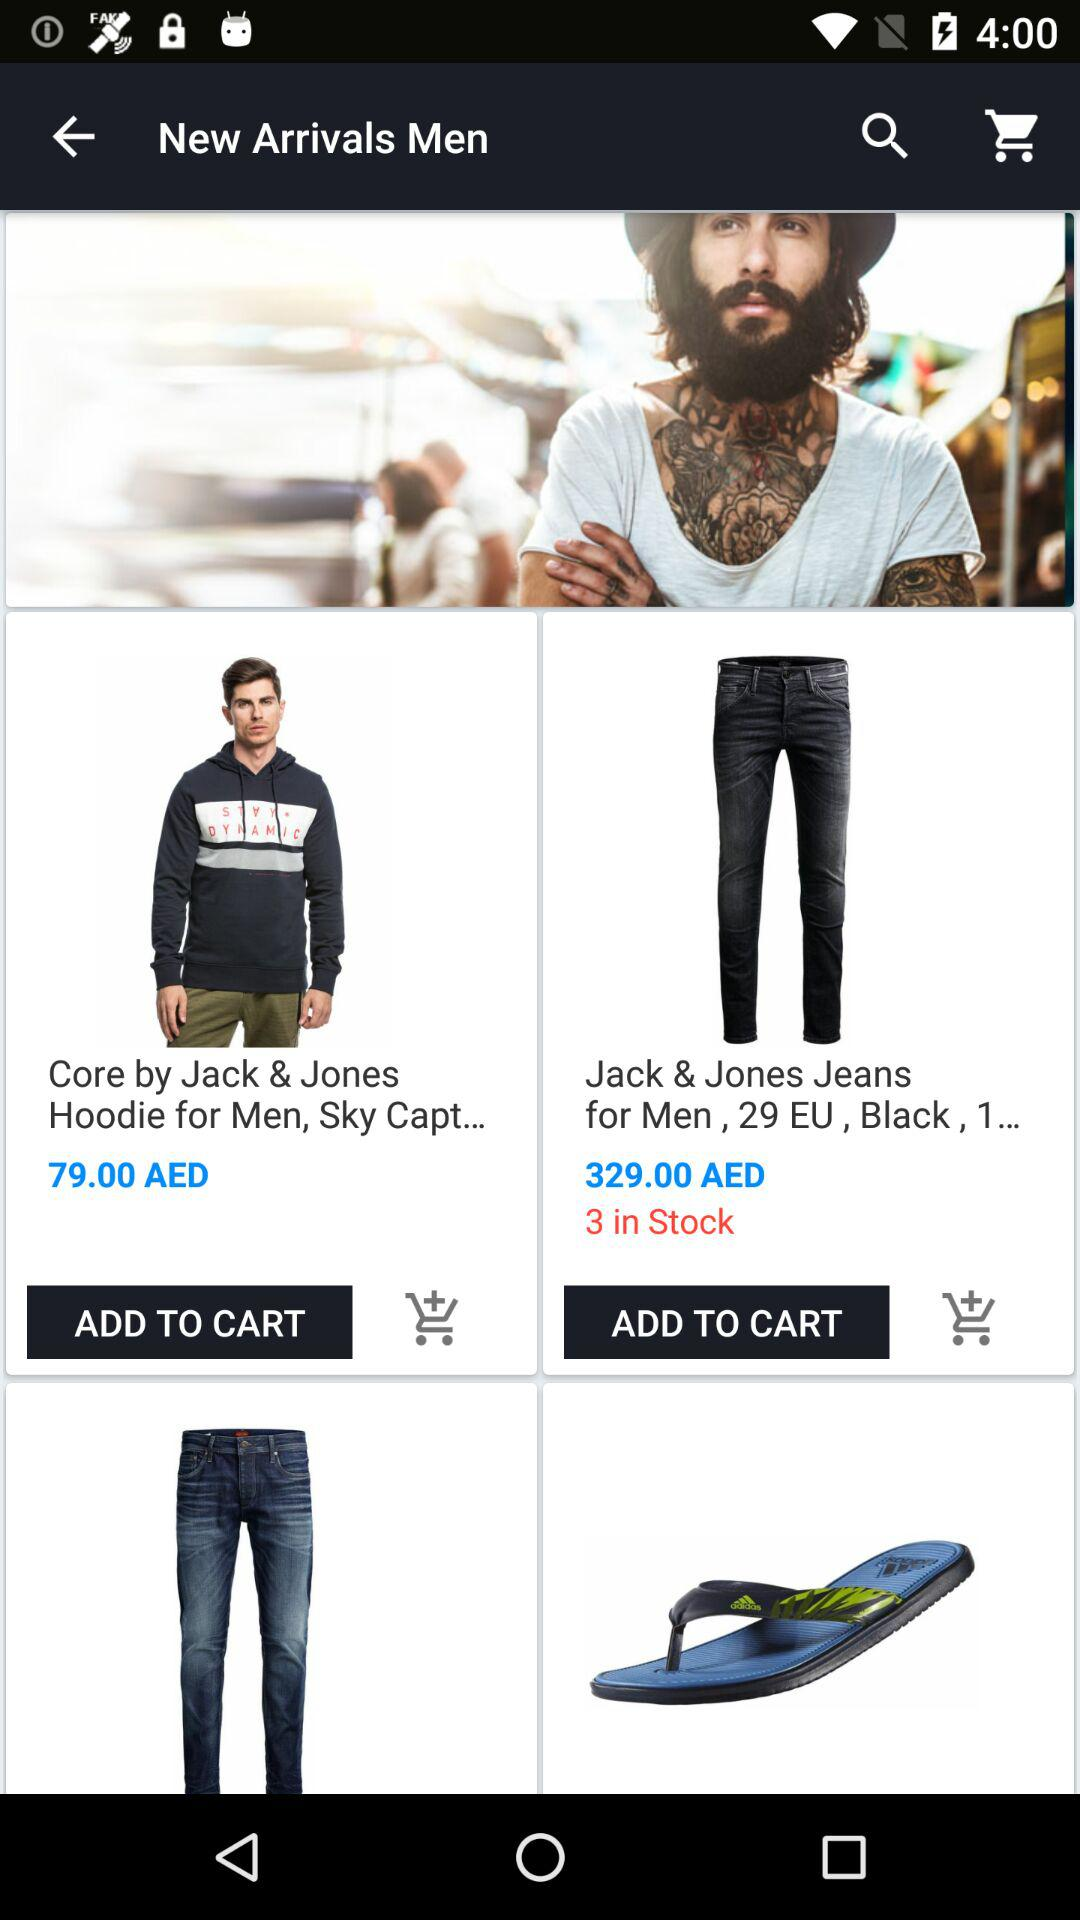How many Jack and Jones jeans are in stock? The number of Jack and Jones jeans in stock is 3. 